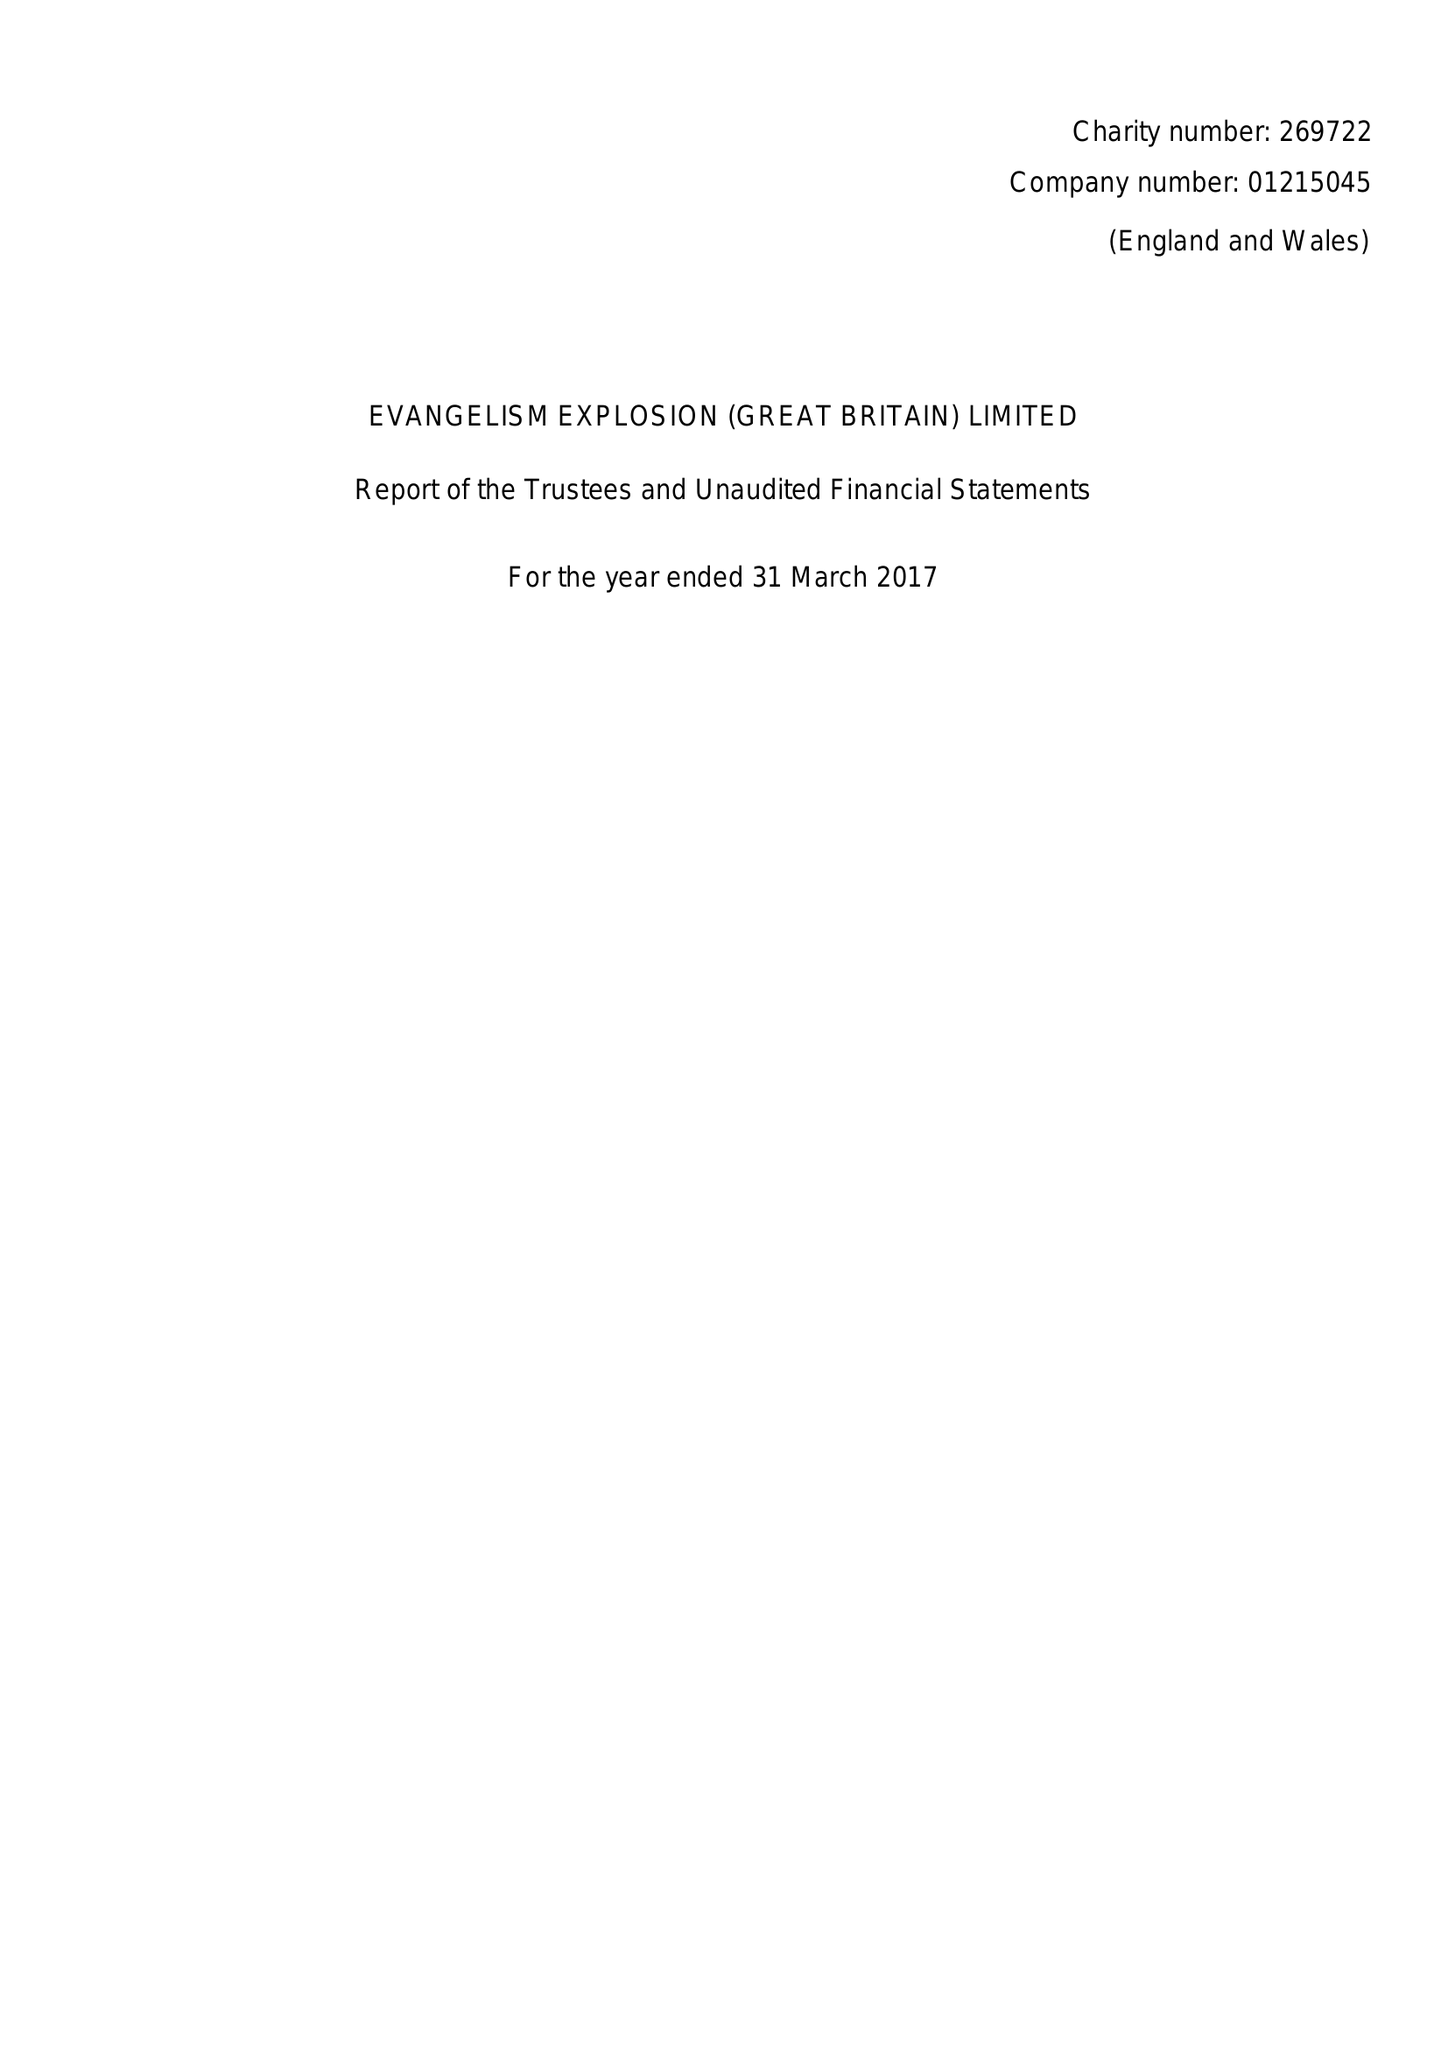What is the value for the address__street_line?
Answer the question using a single word or phrase. THE LOCKS 